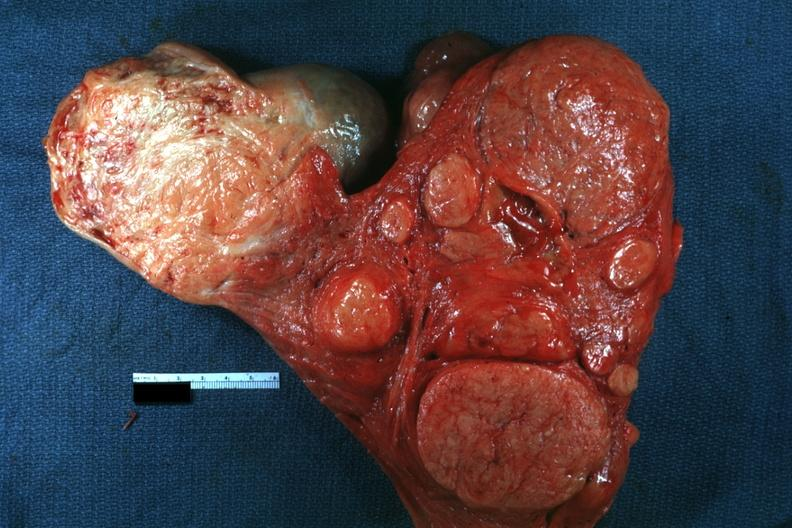what does this image show?
Answer the question using a single word or phrase. Multiple typical lesions good depiction 